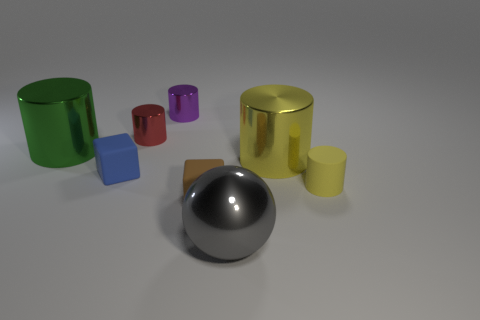There is a gray sphere that is made of the same material as the small red thing; what is its size?
Give a very brief answer. Large. How many large things are either red metallic objects or green metallic cylinders?
Ensure brevity in your answer.  1. What size is the rubber object to the right of the metal cylinder that is in front of the big object to the left of the large gray metal sphere?
Provide a short and direct response. Small. What number of metallic spheres have the same size as the red metallic object?
Make the answer very short. 0. How many objects are either green objects or small cylinders that are right of the tiny brown thing?
Your answer should be very brief. 2. The tiny brown thing has what shape?
Your answer should be very brief. Cube. There is a matte cube that is the same size as the brown rubber thing; what color is it?
Your response must be concise. Blue. How many blue objects are either tiny blocks or small metal things?
Provide a succinct answer. 1. Is the number of small blue cubes greater than the number of tiny brown metal cylinders?
Keep it short and to the point. Yes. Do the matte thing that is on the left side of the purple cylinder and the yellow thing that is on the left side of the yellow matte thing have the same size?
Make the answer very short. No. 